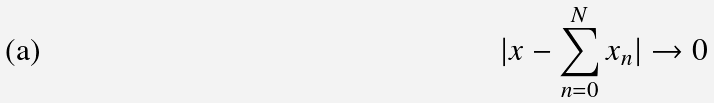<formula> <loc_0><loc_0><loc_500><loc_500>| x - \sum _ { n = 0 } ^ { N } x _ { n } | \rightarrow 0</formula> 